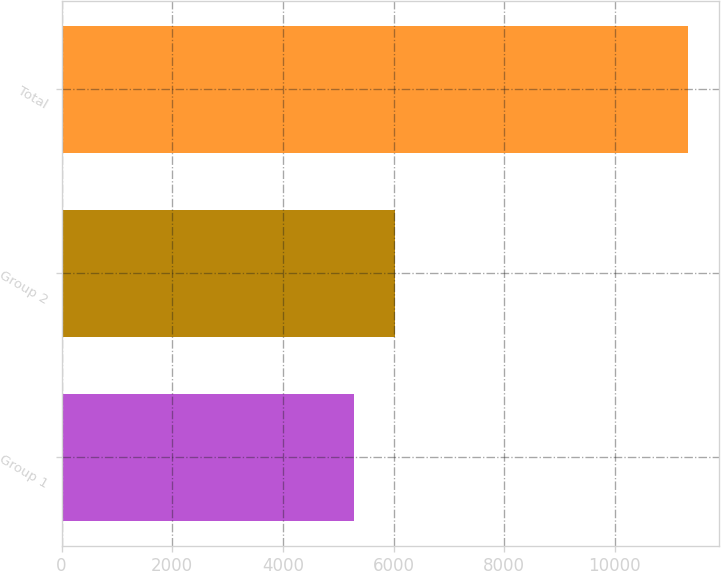Convert chart to OTSL. <chart><loc_0><loc_0><loc_500><loc_500><bar_chart><fcel>Group 1<fcel>Group 2<fcel>Total<nl><fcel>5286.3<fcel>6029.1<fcel>11315.4<nl></chart> 